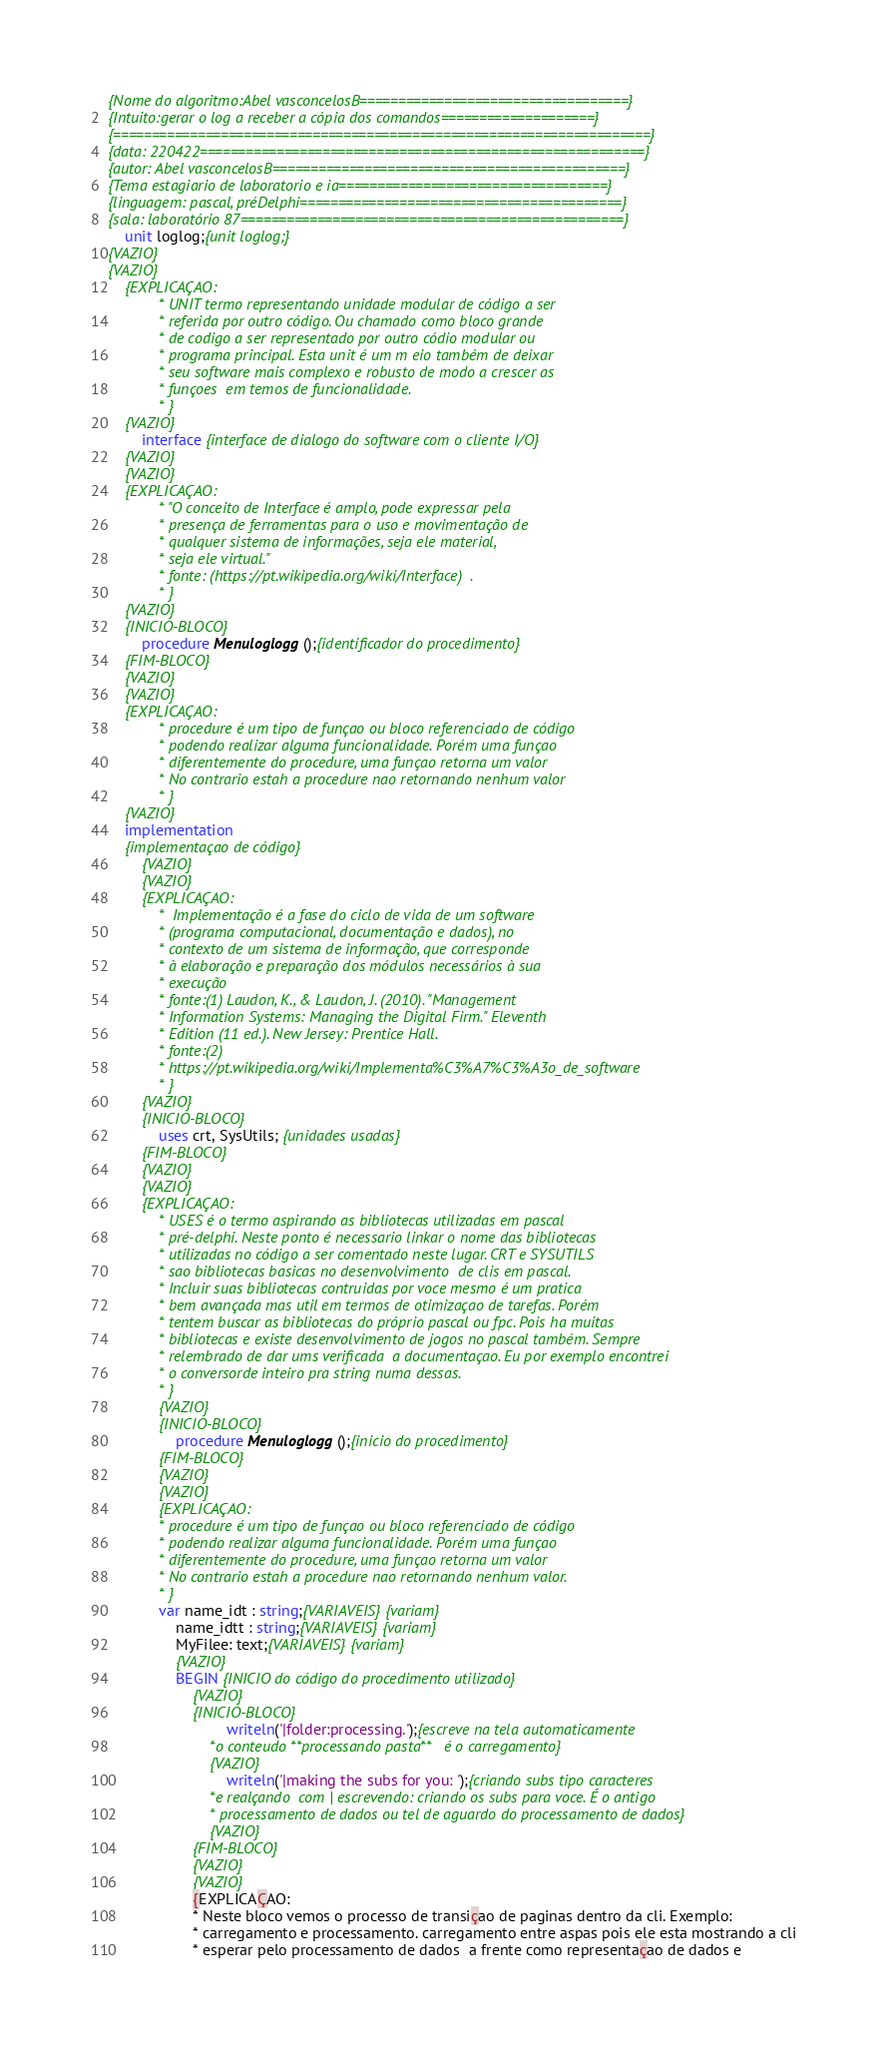Convert code to text. <code><loc_0><loc_0><loc_500><loc_500><_Pascal_>{Nome do algoritmo:Abel vasconcelosB===================================} 
{Intuito:gerar o log a receber a cópia dos comandos====================}
{======================================================================}
{data: 220422==========================================================}
{autor: Abel vasconcelosB==============================================}  
{Tema estagiario de laboratorio e ia===================================} 
{linguagem: pascal, préDelphi==========================================}
{sala: laboratório 87==================================================}
	unit loglog;{unit loglog;}
{VAZIO} 
{VAZIO}
	{EXPLICAÇAO:  
            * UNIT termo representando unidade modular de código a ser    
            * referida por outro código. Ou chamado como bloco grande
            * de codigo a ser representado por outro códio modular ou
            * programa principal. Esta unit é um m eio também de deixar
            * seu software mais complexo e robusto de modo a crescer as
            * funçoes  em temos de funcionalidade.  
            * }
    {VAZIO}
		interface {interface de dialogo do software com o cliente I/O} 
	{VAZIO} 
	{VAZIO}
	{EXPLICAÇAO:
	        * "O conceito de Interface é amplo, pode expressar pela 
	        * presença de ferramentas para o uso e movimentação de 
	        * qualquer sistema de informações, seja ele material, 
	        * seja ele virtual."       
	        * fonte: (https://pt.wikipedia.org/wiki/Interface)  .
            * }
    {VAZIO} 
	{INICIO-BLOCO}
		procedure Menuloglogg();{identificador do procedimento} 
    {FIM-BLOCO}
	{VAZIO} 
	{VAZIO}
	{EXPLICAÇAO:  
            * procedure é um tipo de funçao ou bloco referenciado de código
            * podendo realizar alguma funcionalidade. Porém uma funçao
            * diferentemente do procedure, uma funçao retorna um valor
            * No contrario estah a procedure nao retornando nenhum valor
            * }
	{VAZIO}
	implementation
	{implementaçao de código} 
		{VAZIO} 
		{VAZIO}
	    {EXPLICAÇAO:  
            *  Implementação é a fase do ciclo de vida de um software 
            * (programa computacional, documentação e dados), no 
            * contexto de um sistema de informação, que corresponde 
            * à elaboração e preparação dos módulos necessários à sua
            * execução   
            * fonte:(1) Laudon, K., & Laudon, J. (2010). "Management 
            * Information Systems: Managing the Digital Firm." Eleventh 
            * Edition (11 ed.). New Jersey: Prentice Hall.
            * fonte:(2) 
            * https://pt.wikipedia.org/wiki/Implementa%C3%A7%C3%A3o_de_software
            * }
        {VAZIO} 
	    {INICIO-BLOCO}
			uses crt, SysUtils; {unidades usadas}
        {FIM-BLOCO}
	    {VAZIO} 
	    {VAZIO}    
	    {EXPLICAÇAO:  
            * USES é o termo aspirando as bibliotecas utilizadas em pascal
            * pré-delphi. Neste ponto é necessario linkar o nome das bibliotecas
            * utilizadas no código a ser comentado neste lugar. CRT e SYSUTILS 
            * sao bibliotecas basicas no desenvolvimento  de clis em pascal.
            * Incluir suas bibliotecas contruidas por voce mesmo é um pratica
            * bem avançada mas util em termos de otimizaçao de tarefas. Porém 
            * tentem buscar as bibliotecas do próprio pascal ou fpc. Pois ha muitas
            * bibliotecas e existe desenvolvimento de jogos no pascal também. Sempre 
            * relembrado de dar ums verificada  a documentaçao. Eu por exemplo encontrei
            * o conversorde inteiro pra string numa dessas.
            * }    
            {VAZIO} 
            {INICIO-BLOCO}
				procedure Menuloglogg();{inicio do procedimento}
			{FIM-BLOCO}
            {VAZIO} 
            {VAZIO} 
            {EXPLICAÇAO:  
            * procedure é um tipo de funçao ou bloco referenciado de código
            * podendo realizar alguma funcionalidade. Porém uma funçao
            * diferentemente do procedure, uma funçao retorna um valor
            * No contrario estah a procedure nao retornando nenhum valor.                       
            * }
			var name_idt : string;{VARIAVEIS}{variam} 
				name_idtt : string;{VARIAVEIS}{variam}  
				MyFilee: text;{VARIAVEIS}{variam} 
				{VAZIO}
				BEGIN {INICIO do código do procedimento utilizado}
					{VAZIO}
					{INICIO-BLOCO} 
							writeln('|folder:processing.');{escreve na tela automaticamente
						*o conteudo **processando pasta**   é o carregamento}      
						{VAZIO}
							writeln('|making the subs for you: ');{criando subs tipo caracteres 
						*e realçando  com | escrevendo: criando os subs para voce. É o antigo
						* processamento de dados ou tel de aguardo do processamento de dados} 
						{VAZIO}
	                {FIM-BLOCO}
	                {VAZIO}
	                {VAZIO}
	                {EXPLICAÇAO:  
					* Neste bloco vemos o processo de transiçao de paginas dentro da cli. Exemplo: 
					* carregamento e processamento. carregamento entre aspas pois ele esta mostrando a cli
					* esperar pelo processamento de dados  a frente como representaçao de dados e  </code> 